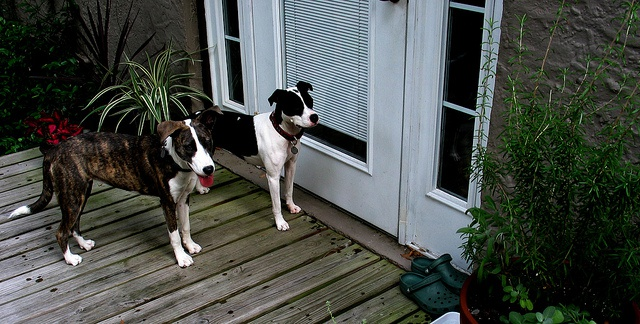Describe the objects in this image and their specific colors. I can see potted plant in black, darkgreen, gray, and darkgray tones, dog in black, gray, white, and maroon tones, dog in black, lightgray, darkgray, and gray tones, potted plant in black, gray, and darkgreen tones, and potted plant in black, maroon, and brown tones in this image. 